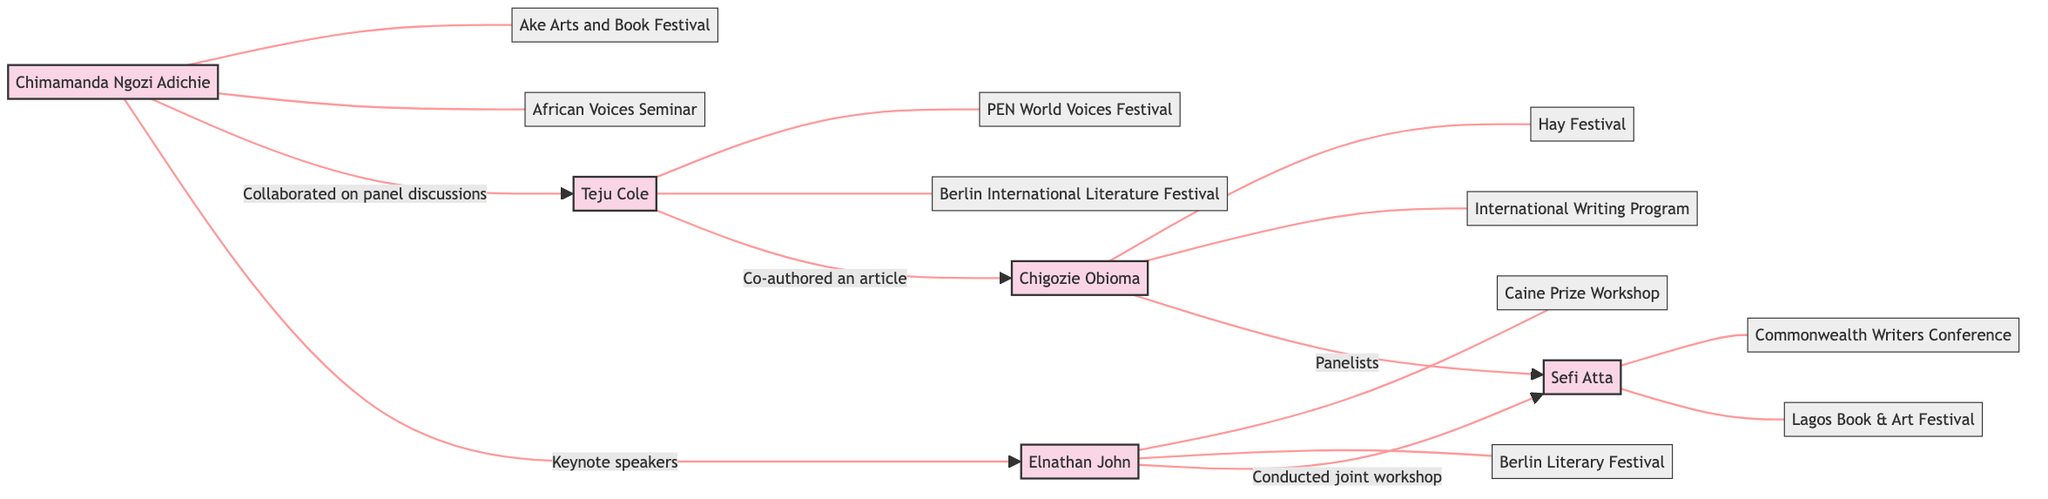What is the total number of nodes in the diagram? By counting each unique individual or event represented in the diagram, there are 5 authors and 9 events, resulting in a total of 14 nodes.
Answer: 14 Which authors attended the Ake Arts and Book Festival? The Ake Arts and Book Festival is connected to Chimamanda Ngozi Adichie as a participant. The diagram shows that only Chimamanda is linked to this event.
Answer: Chimamanda Ngozi Adichie Who collaborated on panel discussions at the PEN World Voices Festival? The edge connecting Chimamanda Ngozi Adichie and Teju Cole explicitly states they collaborated at the PEN World Voices Festival, indicating a partnership between these two authors.
Answer: Chimamanda Ngozi Adichie and Teju Cole How many edges are there in the diagram? By counting the connections between the nodes (relationships) shown in the diagram, there are a total of 5 edges.
Answer: 5 Which author co-authored an article on African literature? The line connecting Teju Cole to Chigozie Obioma indicates that they co-authored an article specifically on African literature, highlighting their collaborative efforts.
Answer: Teju Cole What event was Elnathan John part of alongside Sefi Atta? The edge indicating the collaboration between Elnathan John and Sefi Atta points out that they conducted a joint workshop specifically at the Lagos Book & Art Festival.
Answer: Lagos Book & Art Festival Which two authors were keynote speakers at the Ake Arts and Book Festival? The diagram clearly depicts a connection where both Chimamanda Ngozi Adichie and Elnathan John are noted as keynote speakers, indicating their participation in this capacity.
Answer: Chimamanda Ngozi Adichie and Elnathan John How many events did Teju Cole participate in according to the diagram? The diagram shows that Teju Cole is linked to two events, the PEN World Voices Festival and the Berlin International Literature Festival, confirming his participation in both.
Answer: 2 Which authors are connected through the Hay Festival? The edge indicates that both Chigozie Obioma and Sefi Atta are connected as panelists at the Hay Festival, showing their joint participation in this event.
Answer: Chigozie Obioma and Sefi Atta 